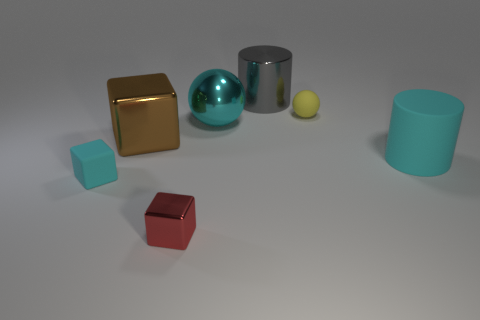There is a big cyan rubber thing on the right side of the big brown metallic thing; is its shape the same as the object behind the small yellow matte sphere?
Provide a succinct answer. Yes. How many things are both on the right side of the red cube and behind the big cyan rubber cylinder?
Offer a terse response. 3. What number of other things are there of the same size as the gray metal cylinder?
Give a very brief answer. 3. There is a small object that is both behind the red metallic block and to the left of the metallic ball; what is it made of?
Provide a short and direct response. Rubber. Do the matte block and the cylinder on the right side of the big gray cylinder have the same color?
Provide a short and direct response. Yes. The other cyan object that is the same shape as the small metal object is what size?
Ensure brevity in your answer.  Small. There is a large shiny object that is both behind the big brown metallic cube and in front of the small sphere; what shape is it?
Offer a terse response. Sphere. Does the rubber cylinder have the same size as the cyan thing left of the red thing?
Provide a short and direct response. No. What color is the other thing that is the same shape as the tiny yellow matte thing?
Offer a very short reply. Cyan. There is a thing on the left side of the brown metallic block; is its size the same as the cyan matte object that is on the right side of the metallic ball?
Make the answer very short. No. 